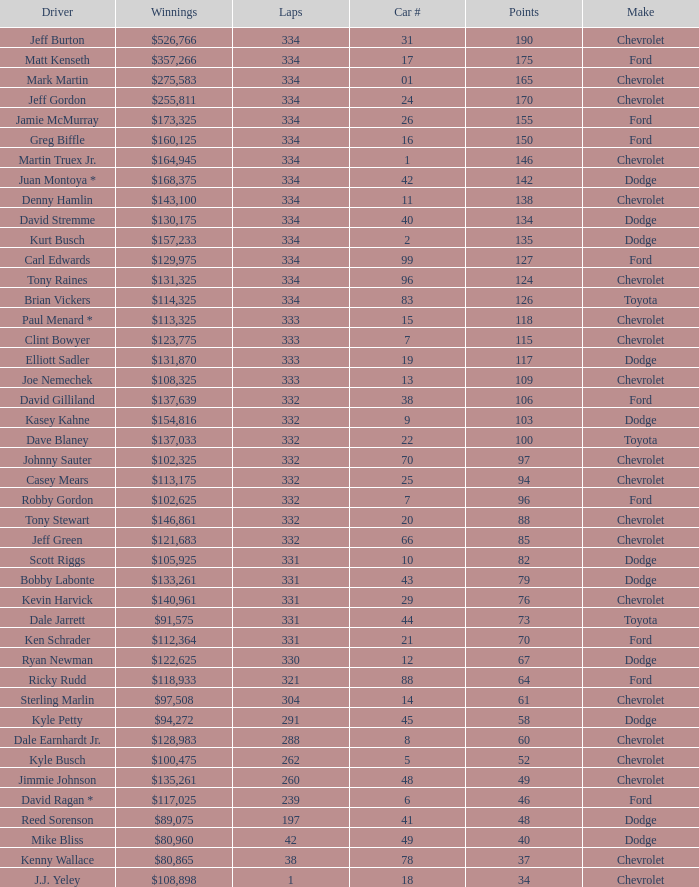How many total laps did the Chevrolet that won $97,508 make? 1.0. 